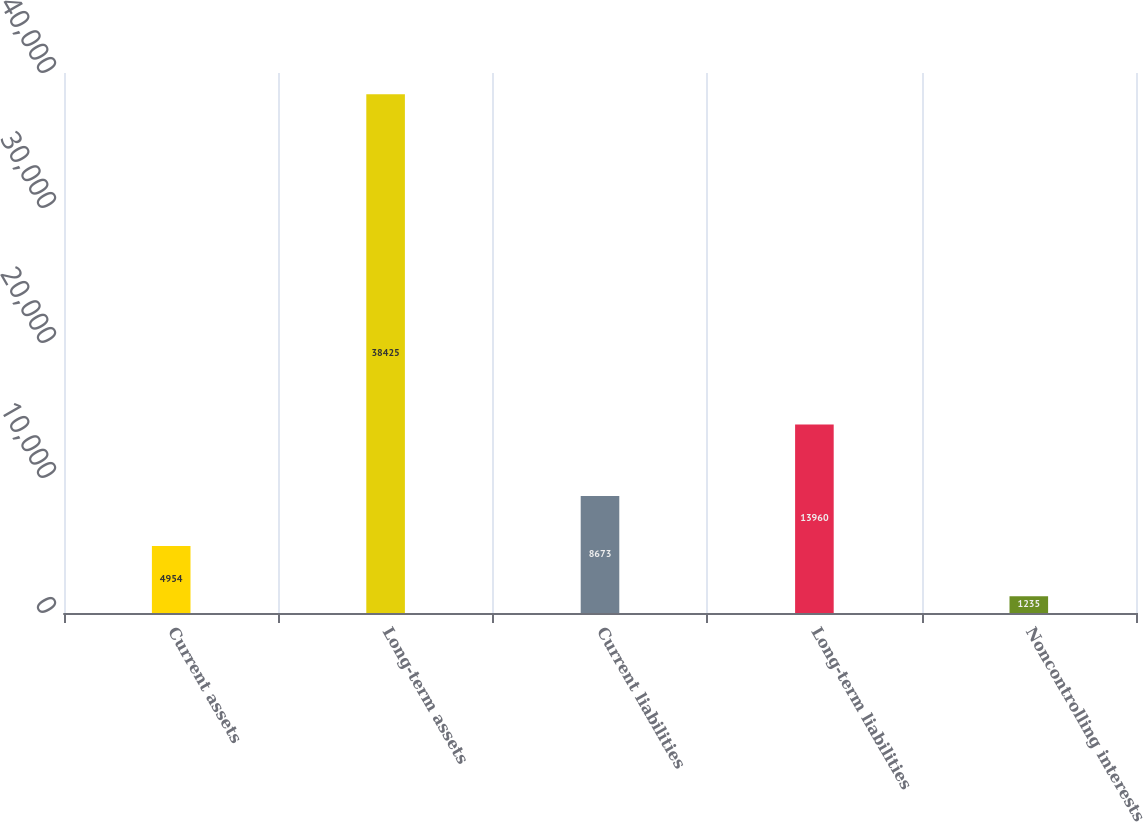Convert chart. <chart><loc_0><loc_0><loc_500><loc_500><bar_chart><fcel>Current assets<fcel>Long-term assets<fcel>Current liabilities<fcel>Long-term liabilities<fcel>Noncontrolling interests<nl><fcel>4954<fcel>38425<fcel>8673<fcel>13960<fcel>1235<nl></chart> 